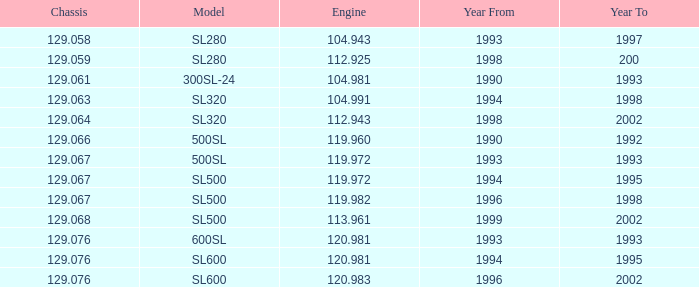Which Engine has a Model of sl500, and a Chassis smaller than 129.067? None. 